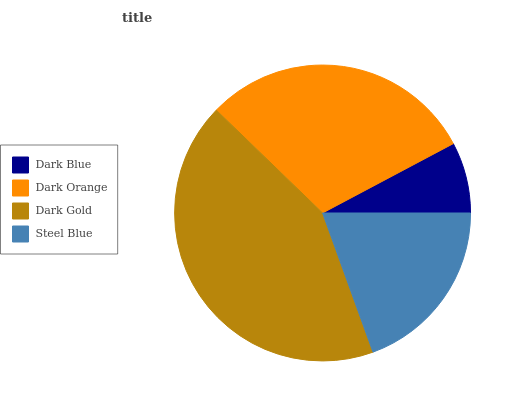Is Dark Blue the minimum?
Answer yes or no. Yes. Is Dark Gold the maximum?
Answer yes or no. Yes. Is Dark Orange the minimum?
Answer yes or no. No. Is Dark Orange the maximum?
Answer yes or no. No. Is Dark Orange greater than Dark Blue?
Answer yes or no. Yes. Is Dark Blue less than Dark Orange?
Answer yes or no. Yes. Is Dark Blue greater than Dark Orange?
Answer yes or no. No. Is Dark Orange less than Dark Blue?
Answer yes or no. No. Is Dark Orange the high median?
Answer yes or no. Yes. Is Steel Blue the low median?
Answer yes or no. Yes. Is Dark Gold the high median?
Answer yes or no. No. Is Dark Blue the low median?
Answer yes or no. No. 